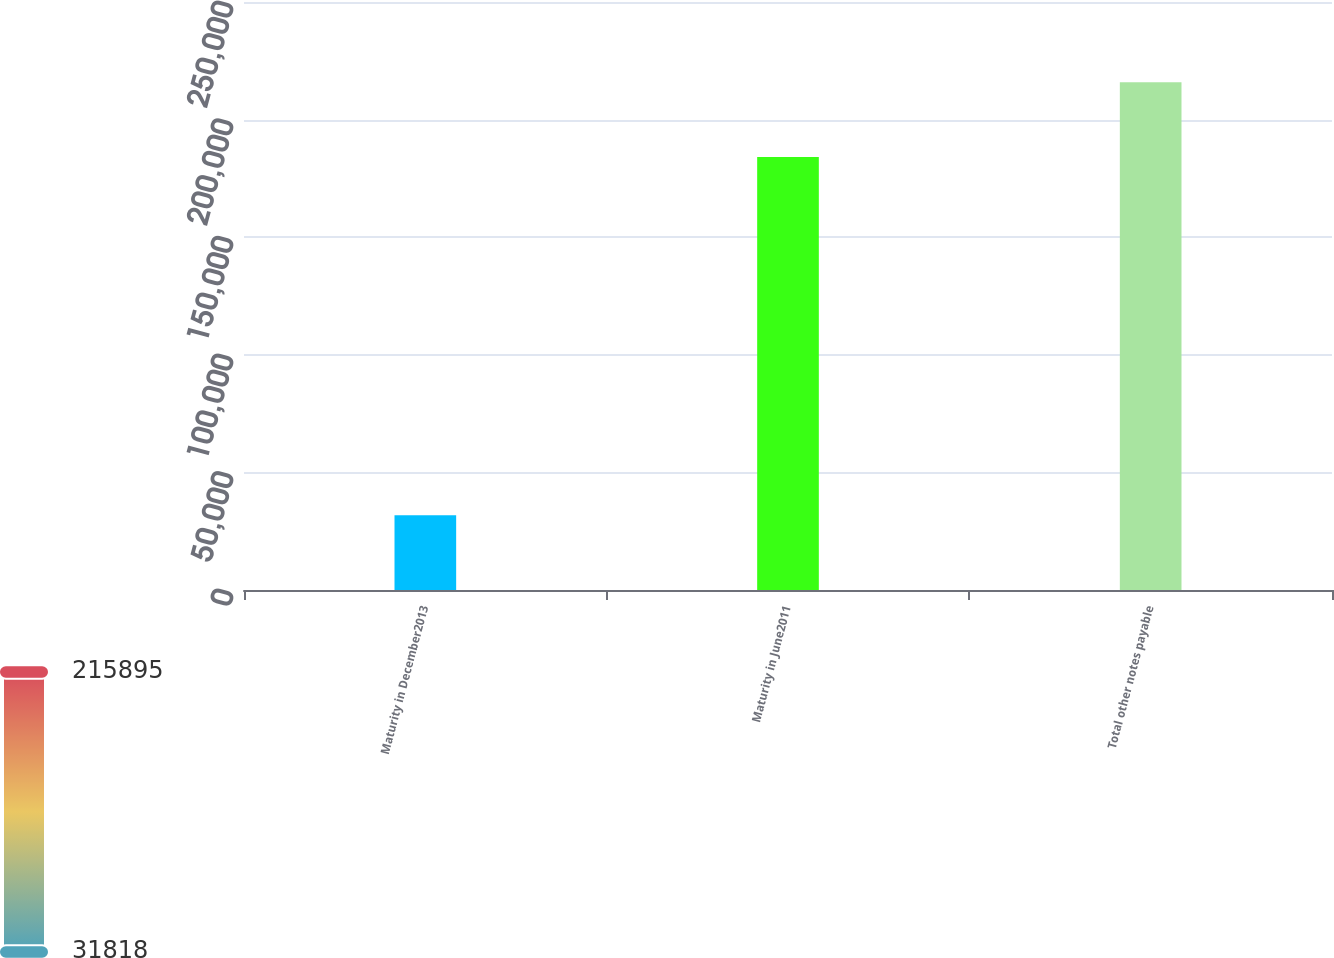<chart> <loc_0><loc_0><loc_500><loc_500><bar_chart><fcel>Maturity in December2013<fcel>Maturity in June2011<fcel>Total other notes payable<nl><fcel>31818<fcel>184077<fcel>215895<nl></chart> 